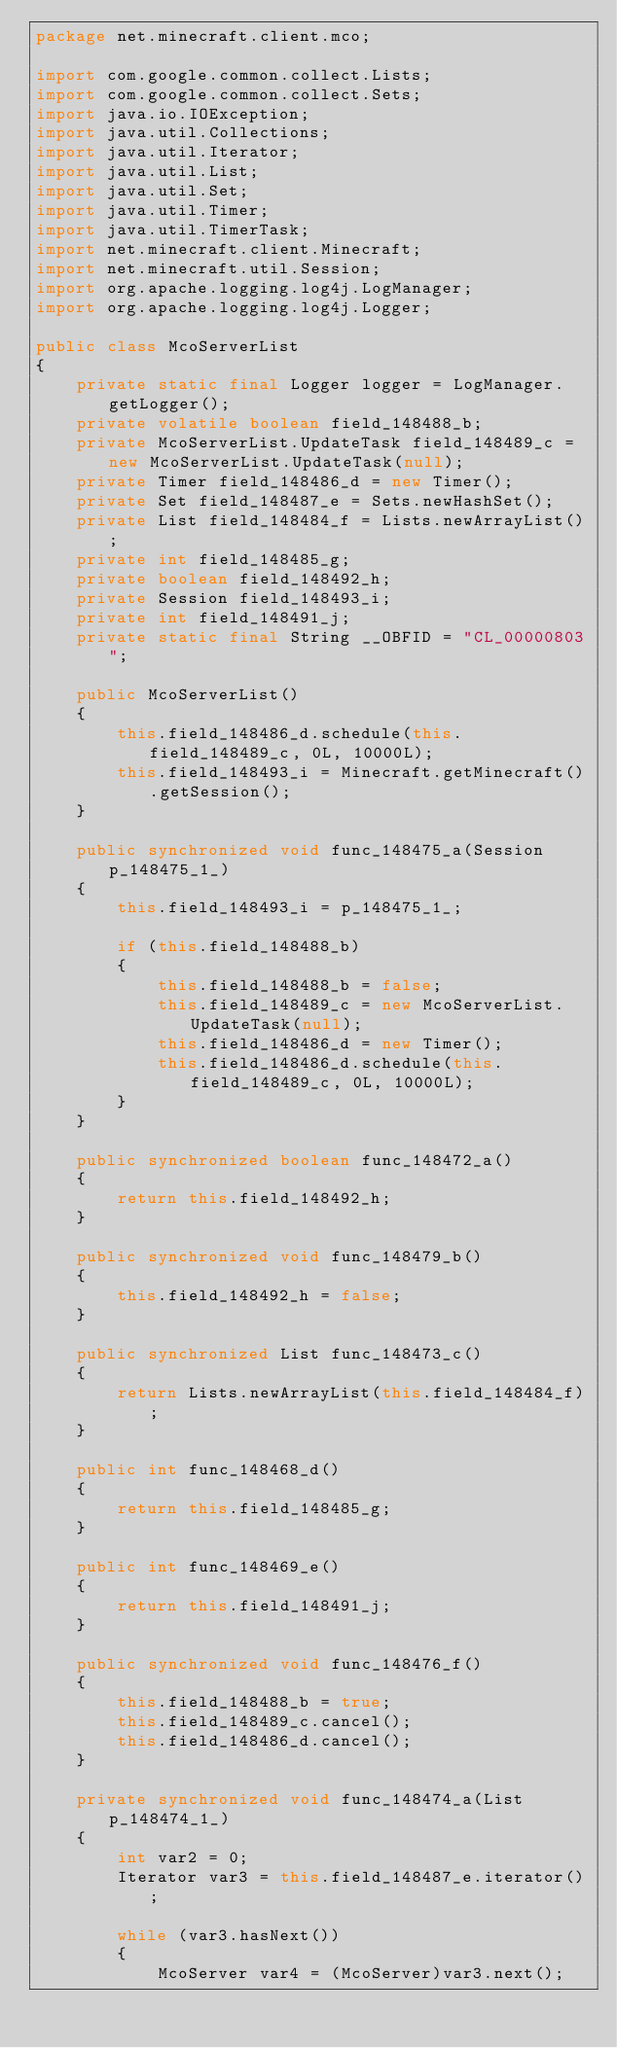<code> <loc_0><loc_0><loc_500><loc_500><_Java_>package net.minecraft.client.mco;

import com.google.common.collect.Lists;
import com.google.common.collect.Sets;
import java.io.IOException;
import java.util.Collections;
import java.util.Iterator;
import java.util.List;
import java.util.Set;
import java.util.Timer;
import java.util.TimerTask;
import net.minecraft.client.Minecraft;
import net.minecraft.util.Session;
import org.apache.logging.log4j.LogManager;
import org.apache.logging.log4j.Logger;

public class McoServerList
{
    private static final Logger logger = LogManager.getLogger();
    private volatile boolean field_148488_b;
    private McoServerList.UpdateTask field_148489_c = new McoServerList.UpdateTask(null);
    private Timer field_148486_d = new Timer();
    private Set field_148487_e = Sets.newHashSet();
    private List field_148484_f = Lists.newArrayList();
    private int field_148485_g;
    private boolean field_148492_h;
    private Session field_148493_i;
    private int field_148491_j;
    private static final String __OBFID = "CL_00000803";

    public McoServerList()
    {
        this.field_148486_d.schedule(this.field_148489_c, 0L, 10000L);
        this.field_148493_i = Minecraft.getMinecraft().getSession();
    }

    public synchronized void func_148475_a(Session p_148475_1_)
    {
        this.field_148493_i = p_148475_1_;

        if (this.field_148488_b)
        {
            this.field_148488_b = false;
            this.field_148489_c = new McoServerList.UpdateTask(null);
            this.field_148486_d = new Timer();
            this.field_148486_d.schedule(this.field_148489_c, 0L, 10000L);
        }
    }

    public synchronized boolean func_148472_a()
    {
        return this.field_148492_h;
    }

    public synchronized void func_148479_b()
    {
        this.field_148492_h = false;
    }

    public synchronized List func_148473_c()
    {
        return Lists.newArrayList(this.field_148484_f);
    }

    public int func_148468_d()
    {
        return this.field_148485_g;
    }

    public int func_148469_e()
    {
        return this.field_148491_j;
    }

    public synchronized void func_148476_f()
    {
        this.field_148488_b = true;
        this.field_148489_c.cancel();
        this.field_148486_d.cancel();
    }

    private synchronized void func_148474_a(List p_148474_1_)
    {
        int var2 = 0;
        Iterator var3 = this.field_148487_e.iterator();

        while (var3.hasNext())
        {
            McoServer var4 = (McoServer)var3.next();
</code> 